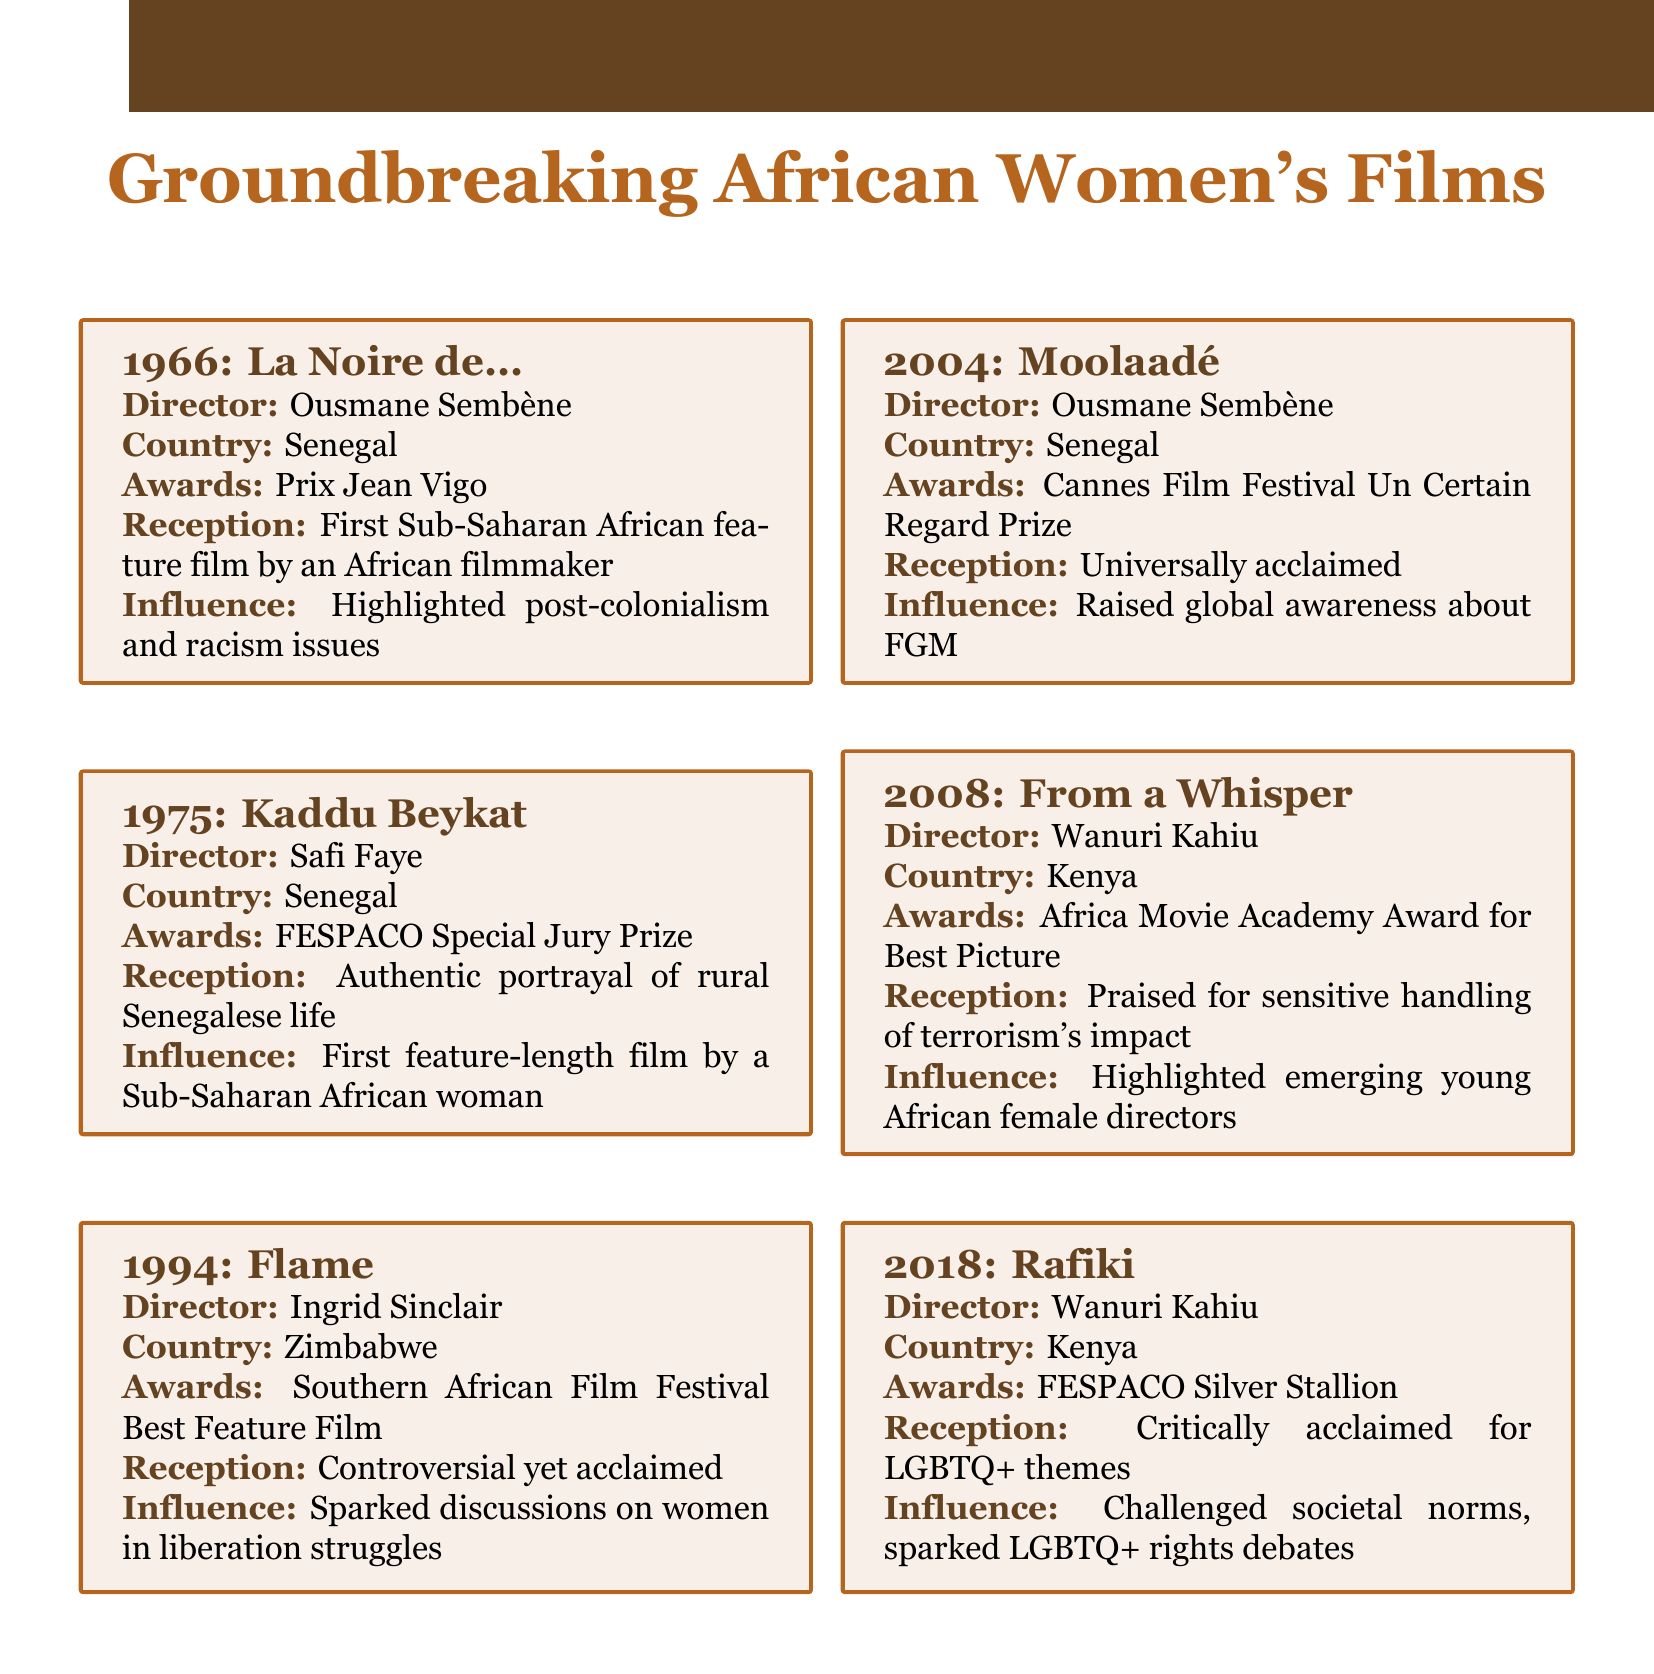What is the title of the first feature film by a Sub-Saharan African woman? The question refers to the film listed as produced by a Sub-Saharan African woman, specifically looking for its title in the catalog.
Answer: Kaddu Beykat Who directed the film "Rafiki"? This inquiry seeks the name of the director associated with the film "Rafiki," mentioned in the document.
Answer: Wanuri Kahiu In what year was "Moolaadé" released? This question asks for the specific year that the film "Moolaadé" was produced, as stated in the catalog.
Answer: 2004 Which country produced the film "From a Whisper"? The aim is to identify the country of origin for "From a Whisper," based on the information provided.
Answer: Kenya What award did "Flame" receive? This asks for the specific award that the film "Flame" was recognized with, as detailed in the document.
Answer: Southern African Film Festival Best Feature Film Which film raised global awareness about FGM? The question looks for the title of the film associated with raising awareness about Female Genital Mutilation, as outlined in the document.
Answer: Moolaadé What theme did "Rafiki" challenge? This question is asking for the societal issue that "Rafiki" addresses, looking for a specific theme presented in the document.
Answer: LGBTQ+ themes Which film was recognized with the FESPACO Silver Stallion? Here, the inquiry seeks to find out which film received this particular award, as mentioned in the catalog.
Answer: Rafiki What significant societal topic did "Flame" spark discussions about? This question is looking for the specific topic linked to the film "Flame," covered in the document.
Answer: women in liberation struggles 